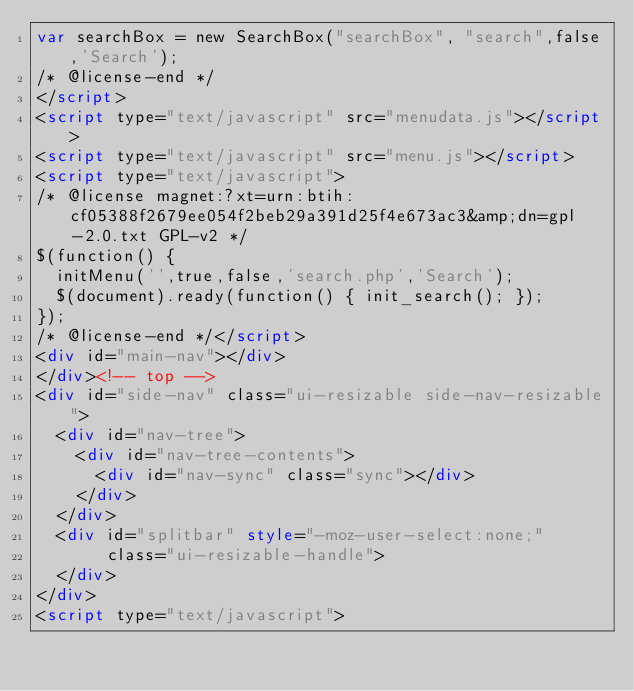Convert code to text. <code><loc_0><loc_0><loc_500><loc_500><_HTML_>var searchBox = new SearchBox("searchBox", "search",false,'Search');
/* @license-end */
</script>
<script type="text/javascript" src="menudata.js"></script>
<script type="text/javascript" src="menu.js"></script>
<script type="text/javascript">
/* @license magnet:?xt=urn:btih:cf05388f2679ee054f2beb29a391d25f4e673ac3&amp;dn=gpl-2.0.txt GPL-v2 */
$(function() {
  initMenu('',true,false,'search.php','Search');
  $(document).ready(function() { init_search(); });
});
/* @license-end */</script>
<div id="main-nav"></div>
</div><!-- top -->
<div id="side-nav" class="ui-resizable side-nav-resizable">
  <div id="nav-tree">
    <div id="nav-tree-contents">
      <div id="nav-sync" class="sync"></div>
    </div>
  </div>
  <div id="splitbar" style="-moz-user-select:none;" 
       class="ui-resizable-handle">
  </div>
</div>
<script type="text/javascript"></code> 